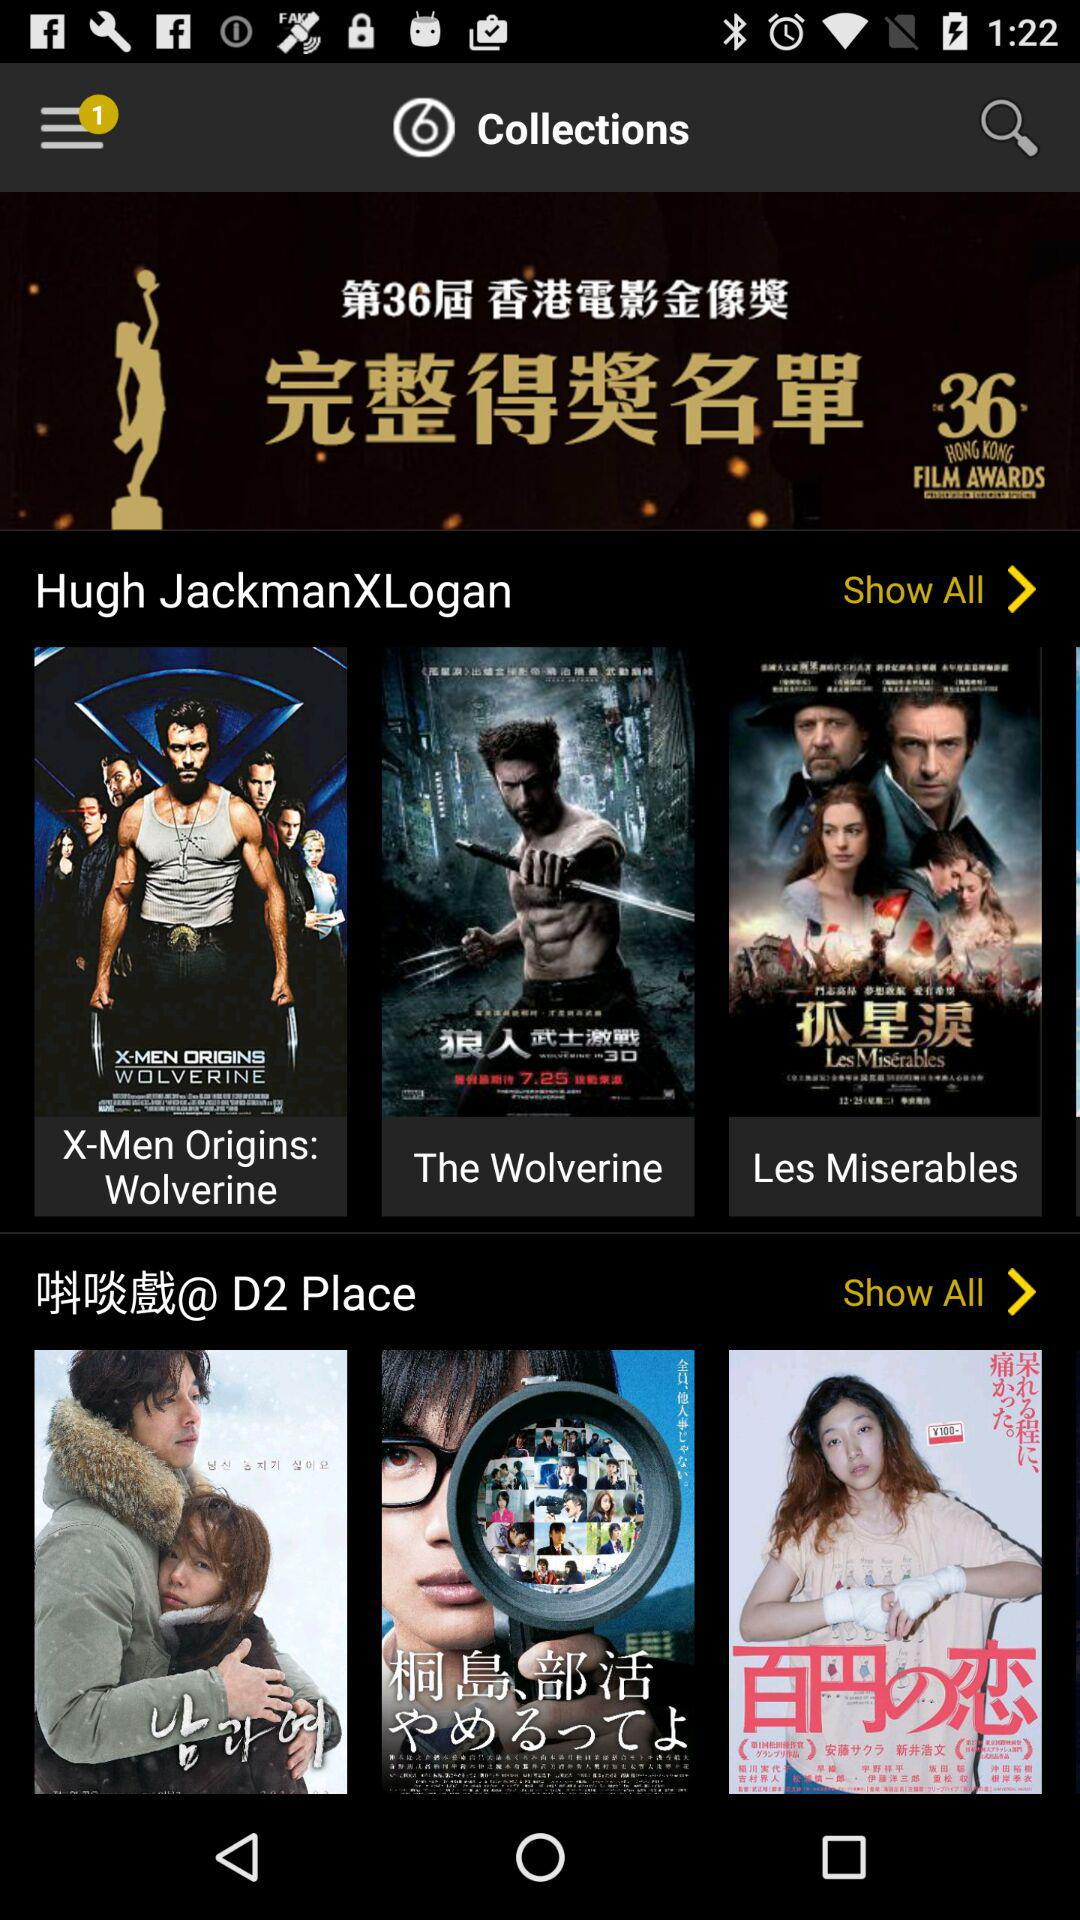What is the duration of "The Wolverine"?
When the provided information is insufficient, respond with <no answer>. <no answer> 